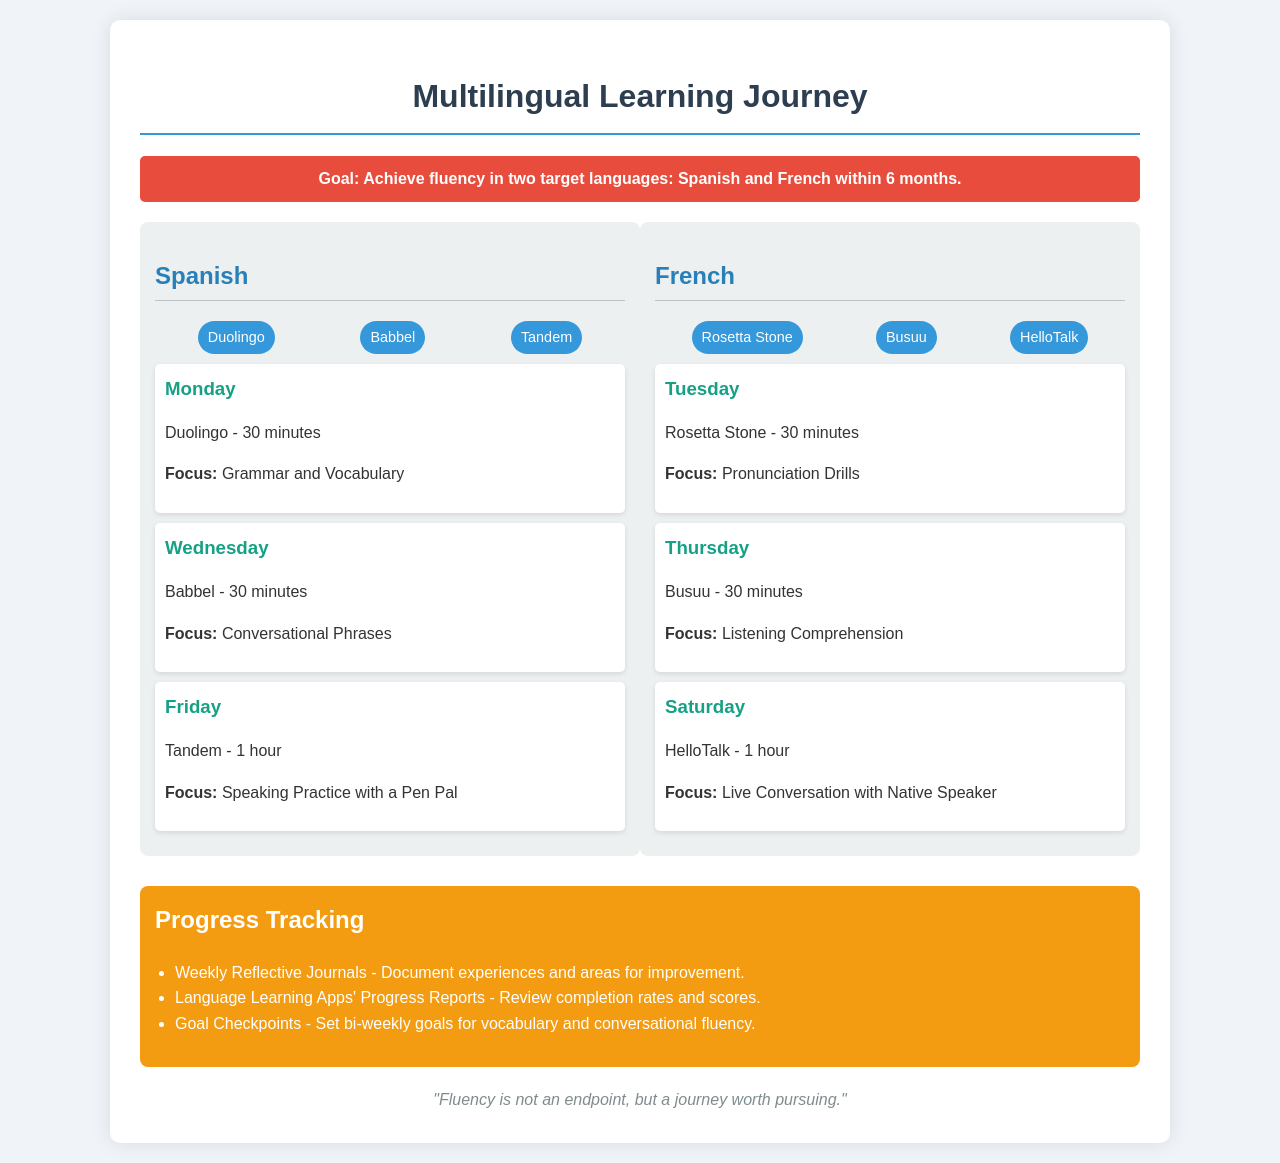What is the primary goal stated in the document? The goal is to achieve fluency in two target languages: Spanish and French within 6 months.
Answer: Achieve fluency in two target languages: Spanish and French within 6 months Which session is scheduled for Tuesday? The session scheduled for Tuesday is with Rosetta Stone for 30 minutes focusing on pronunciation drills.
Answer: Rosetta Stone - 30 minutes How many resources are listed for Spanish? There are three resources listed for Spanish: Duolingo, Babbel, and Tandem.
Answer: 3 What is the focus of the French session on Thursday? The focus of the French session on Thursday is listening comprehension through Busuu.
Answer: Listening Comprehension How often are the goal checkpoints set for vocabulary? The goal checkpoints are set bi-weekly for vocabulary and conversational fluency.
Answer: Bi-weekly What type of reflective practice is mentioned for tracking progress? Weekly reflective journals are mentioned for documenting experiences and areas for improvement.
Answer: Weekly Reflective Journals How many hours of speaking practice are there in total for Spanish? There is a total of 1 hour of speaking practice scheduled with Tandem on Friday.
Answer: 1 hour What time is the Spanish session on Monday? The Spanish session on Monday is for 30 minutes with Duolingo.
Answer: 30 minutes What is the duration of the session on Saturday for French? The duration of the session on Saturday for French is 1 hour with HelloTalk.
Answer: 1 hour 